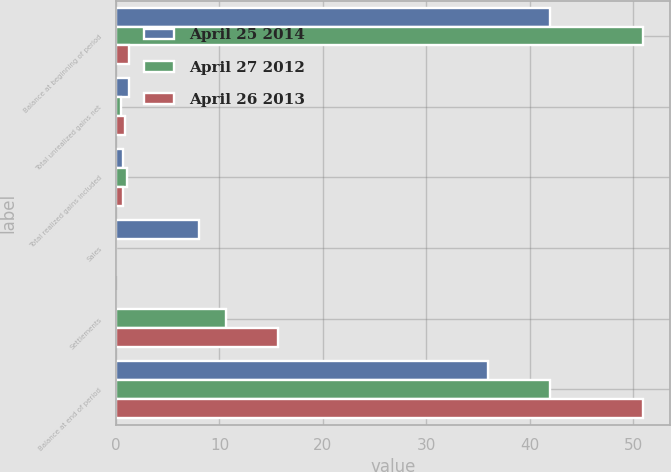Convert chart to OTSL. <chart><loc_0><loc_0><loc_500><loc_500><stacked_bar_chart><ecel><fcel>Balance at beginning of period<fcel>Total unrealized gains net<fcel>Total realized gains included<fcel>Sales<fcel>Settlements<fcel>Balance at end of period<nl><fcel>April 25 2014<fcel>42<fcel>1.3<fcel>0.7<fcel>8<fcel>0<fcel>36<nl><fcel>April 27 2012<fcel>51<fcel>0.5<fcel>1.1<fcel>0<fcel>10.6<fcel>42<nl><fcel>April 26 2013<fcel>1.3<fcel>0.9<fcel>0.7<fcel>0<fcel>15.7<fcel>51<nl></chart> 